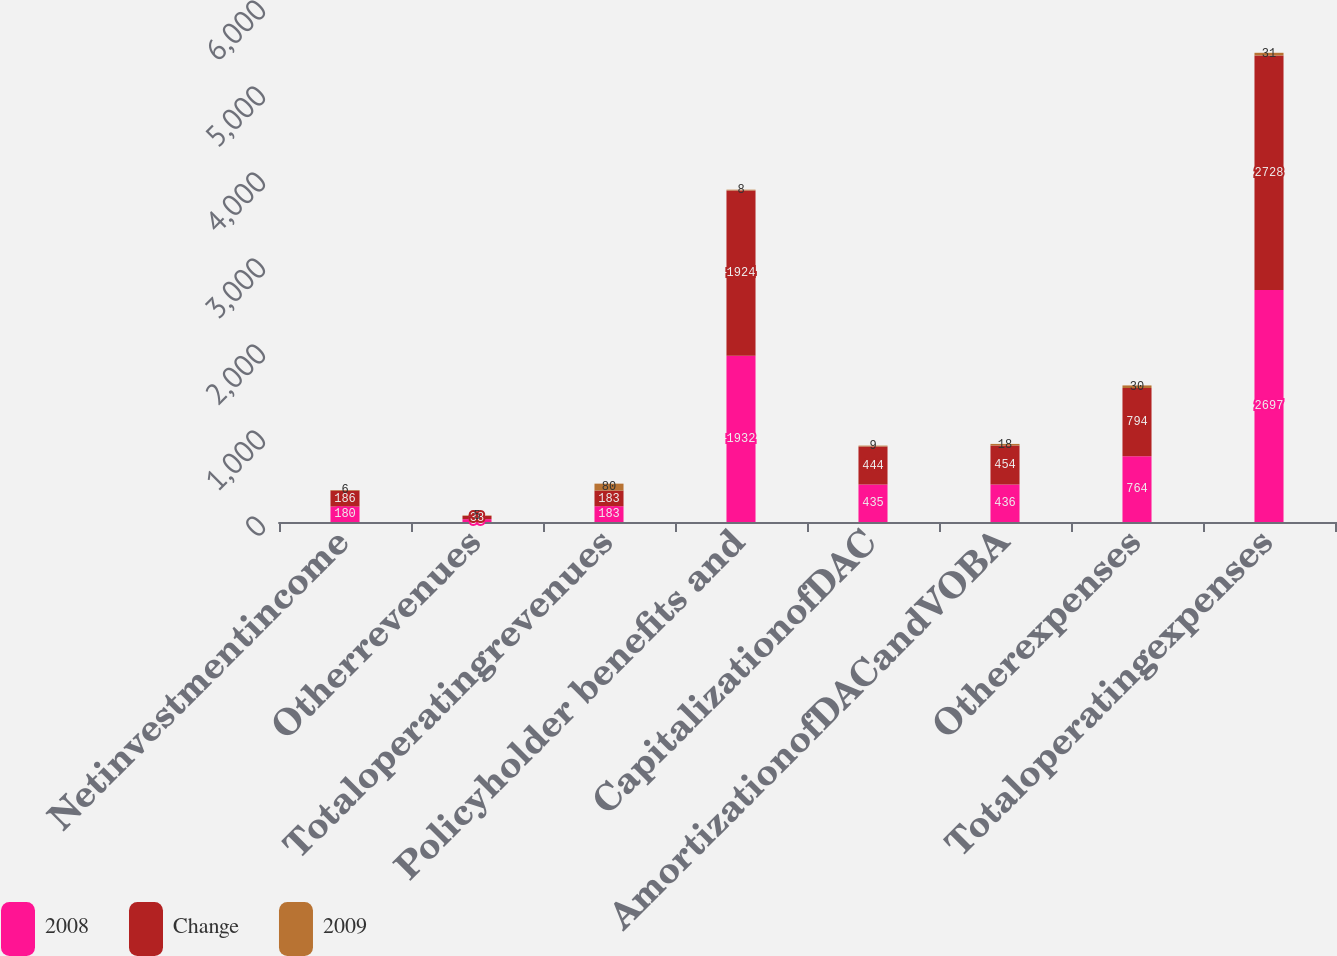<chart> <loc_0><loc_0><loc_500><loc_500><stacked_bar_chart><ecel><fcel>Netinvestmentincome<fcel>Otherrevenues<fcel>Totaloperatingrevenues<fcel>Policyholder benefits and<fcel>CapitalizationofDAC<fcel>AmortizationofDACandVOBA<fcel>Otherexpenses<fcel>Totaloperatingexpenses<nl><fcel>2008<fcel>180<fcel>33<fcel>183<fcel>1932<fcel>435<fcel>436<fcel>764<fcel>2697<nl><fcel>Change<fcel>186<fcel>38<fcel>183<fcel>1924<fcel>444<fcel>454<fcel>794<fcel>2728<nl><fcel>2009<fcel>6<fcel>5<fcel>80<fcel>8<fcel>9<fcel>18<fcel>30<fcel>31<nl></chart> 